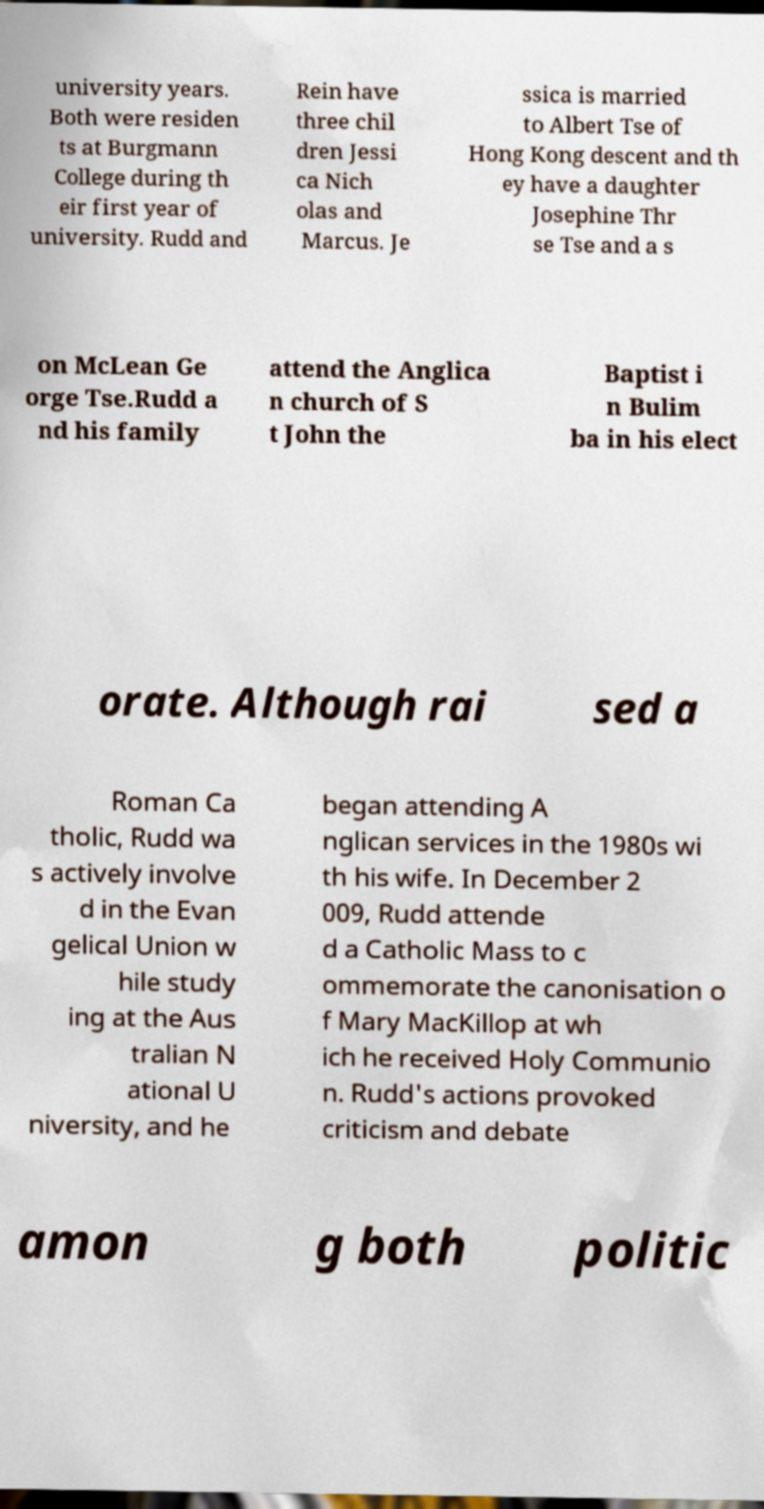Could you assist in decoding the text presented in this image and type it out clearly? university years. Both were residen ts at Burgmann College during th eir first year of university. Rudd and Rein have three chil dren Jessi ca Nich olas and Marcus. Je ssica is married to Albert Tse of Hong Kong descent and th ey have a daughter Josephine Thr se Tse and a s on McLean Ge orge Tse.Rudd a nd his family attend the Anglica n church of S t John the Baptist i n Bulim ba in his elect orate. Although rai sed a Roman Ca tholic, Rudd wa s actively involve d in the Evan gelical Union w hile study ing at the Aus tralian N ational U niversity, and he began attending A nglican services in the 1980s wi th his wife. In December 2 009, Rudd attende d a Catholic Mass to c ommemorate the canonisation o f Mary MacKillop at wh ich he received Holy Communio n. Rudd's actions provoked criticism and debate amon g both politic 